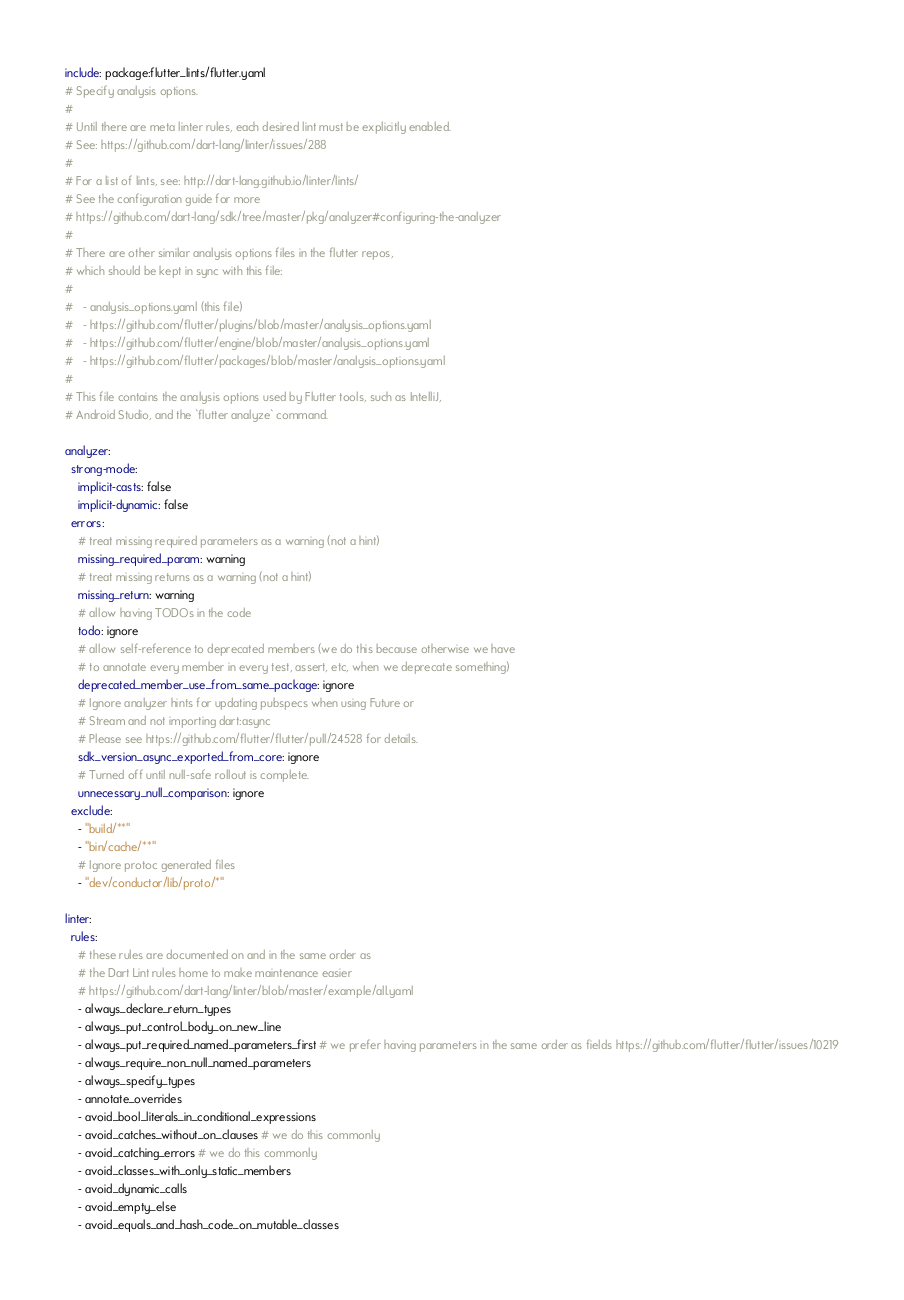Convert code to text. <code><loc_0><loc_0><loc_500><loc_500><_YAML_>include: package:flutter_lints/flutter.yaml
# Specify analysis options.
#
# Until there are meta linter rules, each desired lint must be explicitly enabled.
# See: https://github.com/dart-lang/linter/issues/288
#
# For a list of lints, see: http://dart-lang.github.io/linter/lints/
# See the configuration guide for more
# https://github.com/dart-lang/sdk/tree/master/pkg/analyzer#configuring-the-analyzer
#
# There are other similar analysis options files in the flutter repos,
# which should be kept in sync with this file:
#
#   - analysis_options.yaml (this file)
#   - https://github.com/flutter/plugins/blob/master/analysis_options.yaml
#   - https://github.com/flutter/engine/blob/master/analysis_options.yaml
#   - https://github.com/flutter/packages/blob/master/analysis_options.yaml
#
# This file contains the analysis options used by Flutter tools, such as IntelliJ,
# Android Studio, and the `flutter analyze` command.

analyzer:
  strong-mode:
    implicit-casts: false
    implicit-dynamic: false
  errors:
    # treat missing required parameters as a warning (not a hint)
    missing_required_param: warning
    # treat missing returns as a warning (not a hint)
    missing_return: warning
    # allow having TODOs in the code
    todo: ignore
    # allow self-reference to deprecated members (we do this because otherwise we have
    # to annotate every member in every test, assert, etc, when we deprecate something)
    deprecated_member_use_from_same_package: ignore
    # Ignore analyzer hints for updating pubspecs when using Future or
    # Stream and not importing dart:async
    # Please see https://github.com/flutter/flutter/pull/24528 for details.
    sdk_version_async_exported_from_core: ignore
    # Turned off until null-safe rollout is complete.
    unnecessary_null_comparison: ignore
  exclude:
    - "build/**"
    - "bin/cache/**"
    # Ignore protoc generated files
    - "dev/conductor/lib/proto/*"

linter:
  rules:
    # these rules are documented on and in the same order as
    # the Dart Lint rules home to make maintenance easier
    # https://github.com/dart-lang/linter/blob/master/example/all.yaml
    - always_declare_return_types
    - always_put_control_body_on_new_line
    - always_put_required_named_parameters_first # we prefer having parameters in the same order as fields https://github.com/flutter/flutter/issues/10219
    - always_require_non_null_named_parameters
    - always_specify_types
    - annotate_overrides
    - avoid_bool_literals_in_conditional_expressions
    - avoid_catches_without_on_clauses # we do this commonly
    - avoid_catching_errors # we do this commonly
    - avoid_classes_with_only_static_members
    - avoid_dynamic_calls
    - avoid_empty_else
    - avoid_equals_and_hash_code_on_mutable_classes</code> 